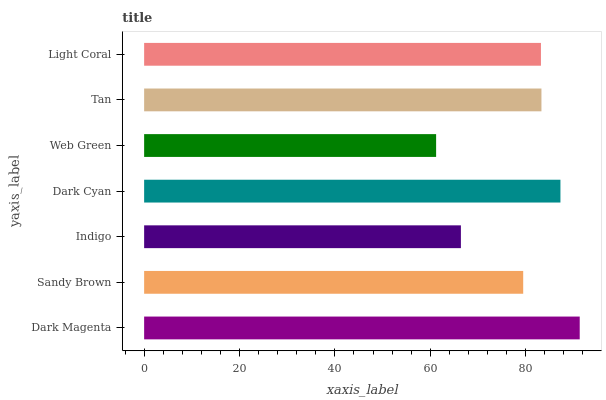Is Web Green the minimum?
Answer yes or no. Yes. Is Dark Magenta the maximum?
Answer yes or no. Yes. Is Sandy Brown the minimum?
Answer yes or no. No. Is Sandy Brown the maximum?
Answer yes or no. No. Is Dark Magenta greater than Sandy Brown?
Answer yes or no. Yes. Is Sandy Brown less than Dark Magenta?
Answer yes or no. Yes. Is Sandy Brown greater than Dark Magenta?
Answer yes or no. No. Is Dark Magenta less than Sandy Brown?
Answer yes or no. No. Is Light Coral the high median?
Answer yes or no. Yes. Is Light Coral the low median?
Answer yes or no. Yes. Is Sandy Brown the high median?
Answer yes or no. No. Is Dark Magenta the low median?
Answer yes or no. No. 